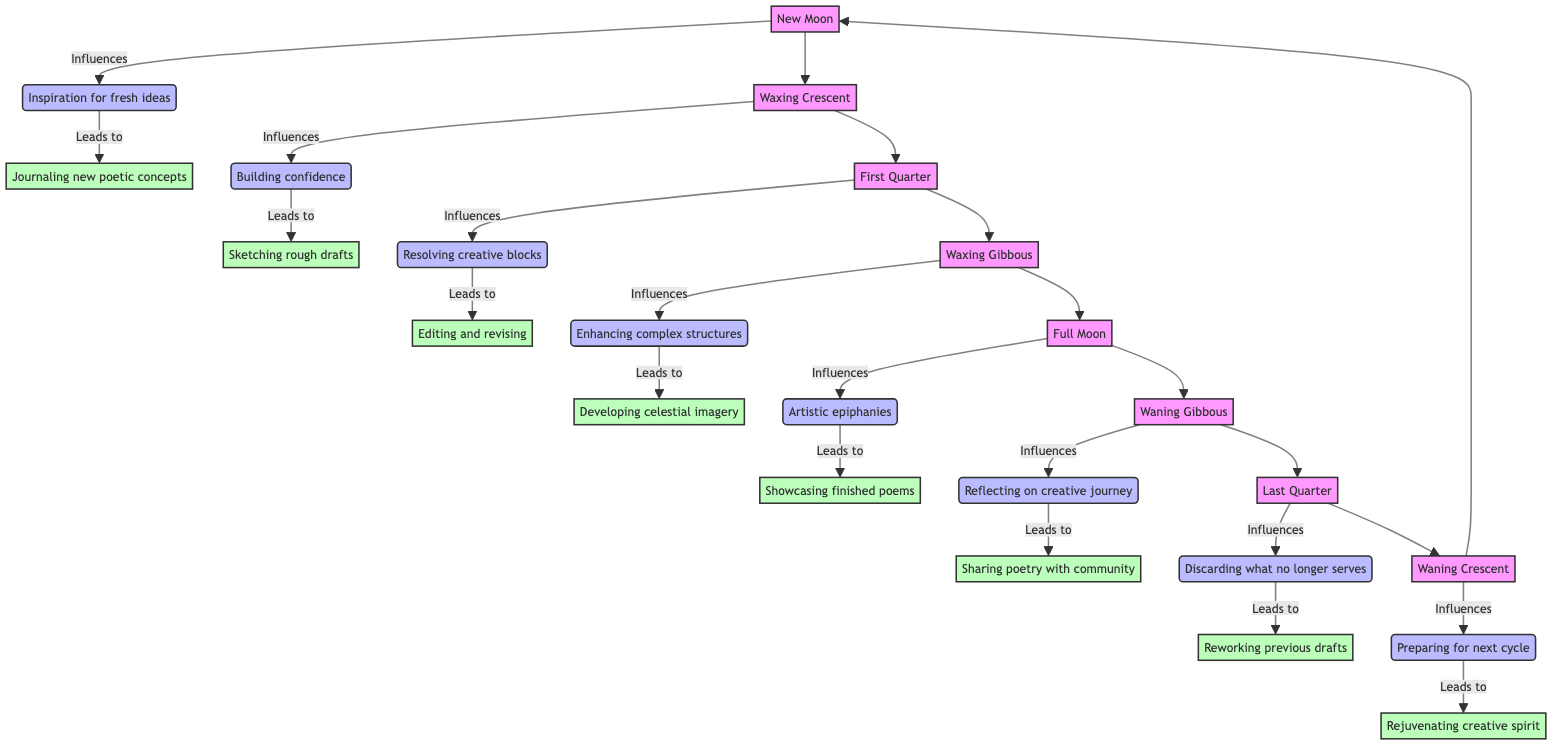What's the influence of the New Moon? The New Moon influences by providing inspiration for fresh ideas. This can be seen directly from the diagram where the New Moon points to its influence on creativity.
Answer: Inspiration for fresh ideas What activity is associated with the Waxing Gibbous? The activity associated with the Waxing Gibbous phase is developing intricate celestial imagery. This is indicated in the diagram where the Waxing Gibbous leads to a specific related activity.
Answer: Developing intricate celestial imagery How many nodes are there in the diagram? By counting each specific phase and its associated effects and activities listed in the diagram, the total number of nodes can be determined. There are eight phases, and each has one influence and one activity, resulting in a total of 24 nodes.
Answer: 24 What follows the Full Moon phase? The Full Moon phase flows into the Waning Gibbous phase. This transition is shown in the flow chart where Full Moon directly points to Waning Gibbous.
Answer: Waning Gibbous Which phase leads to reworking previous drafts? The Last Quarter leads to reworking previous drafts as indicated in the diagram. The Last Quarter directly connects to the specific activity of reworking previous drafts.
Answer: Last Quarter What is the impact on creativity during the Waning Crescent? During the Waning Crescent, the impact on creativity is preparing the mind for the next creative cycle, as directly indicated in the flow chart.
Answer: Preparing for next cycle How does the Waxing Crescent influence creativity? The Waxing Crescent influences creativity by building confidence in artistic expression, which is indicated in the diagram through its respective arrows pointing to impacts.
Answer: Building confidence How many phases lead to showcasing finished poems? Only the Full Moon phase leads to showcasing finished poems, as shown in the diagram with a direct arrow from Full Moon to the related activity.
Answer: One What is the relationship between the New Moon and journaling new poetic concepts? The New Moon directly influences the activity of journaling new poetic concepts, as indicated in the diagram. This shows a clear flow from the New Moon to its connected activity.
Answer: Influences journaling new poetic concepts 